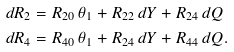Convert formula to latex. <formula><loc_0><loc_0><loc_500><loc_500>d R _ { 2 } & = R _ { 2 0 } \, \theta _ { 1 } + R _ { 2 2 } \, d Y + R _ { 2 4 } \, d Q \\ d R _ { 4 } & = R _ { 4 0 } \, \theta _ { 1 } + R _ { 2 4 } \, d Y + R _ { 4 4 } \, d Q .</formula> 